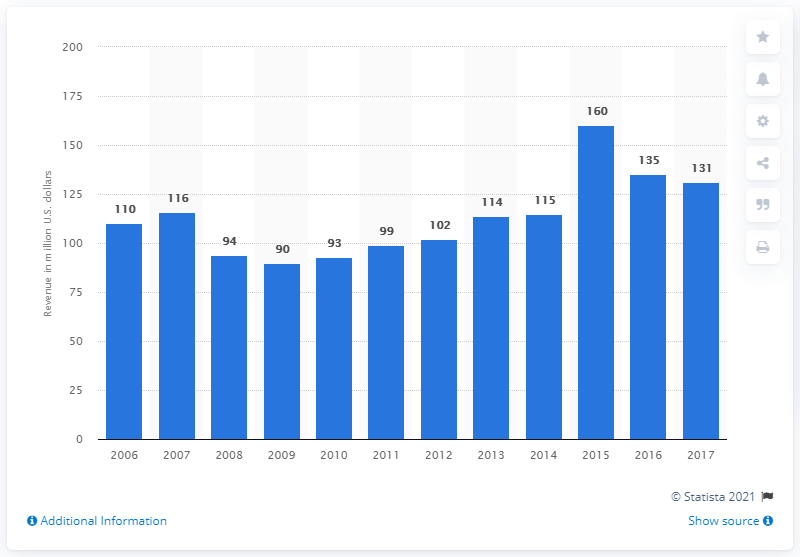Mention a couple of crucial points in this snapshot. In 2011, the revenue of Joe Gibbs Racing was approximately 99 million dollars. 